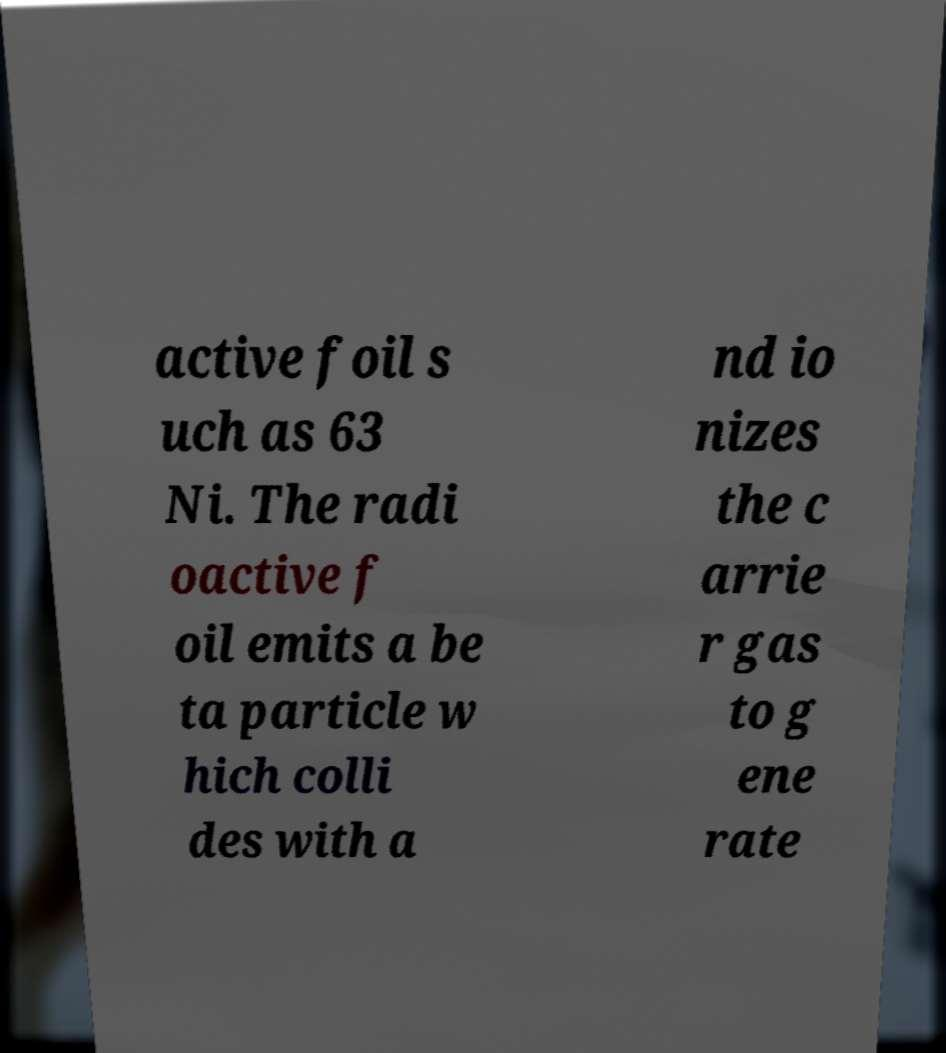Please read and relay the text visible in this image. What does it say? active foil s uch as 63 Ni. The radi oactive f oil emits a be ta particle w hich colli des with a nd io nizes the c arrie r gas to g ene rate 